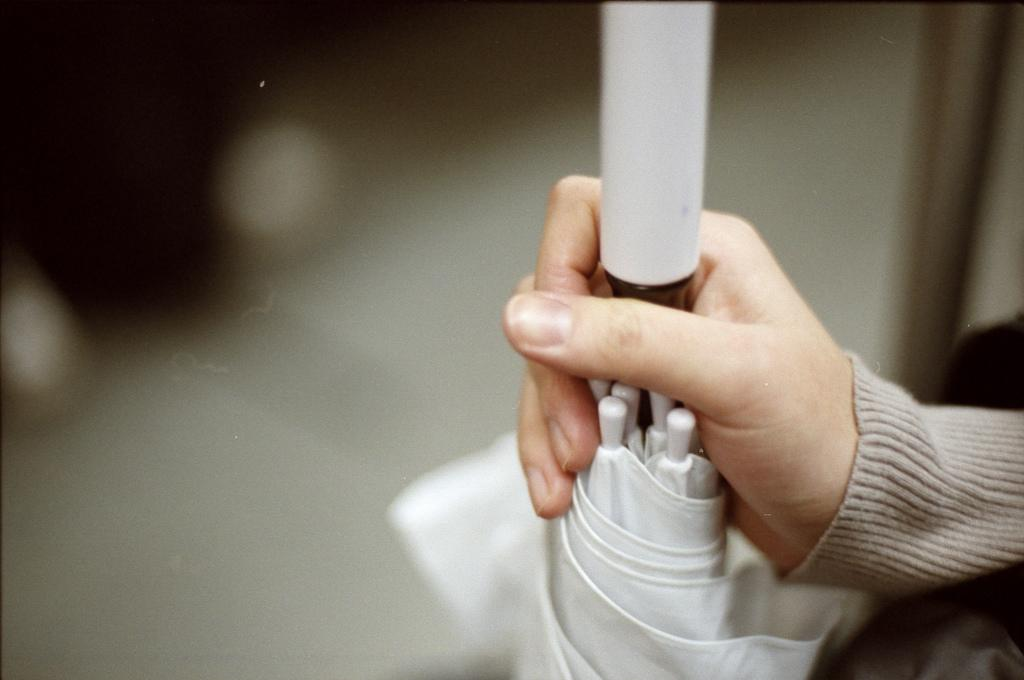What part of the body is visible in the image? There is a person's hand in the image. What is the hand holding? The hand is holding an umbrella. Can you describe the background of the image? The background of the image is blurred. What type of pets can be seen in the image? There are no pets visible in the image. 